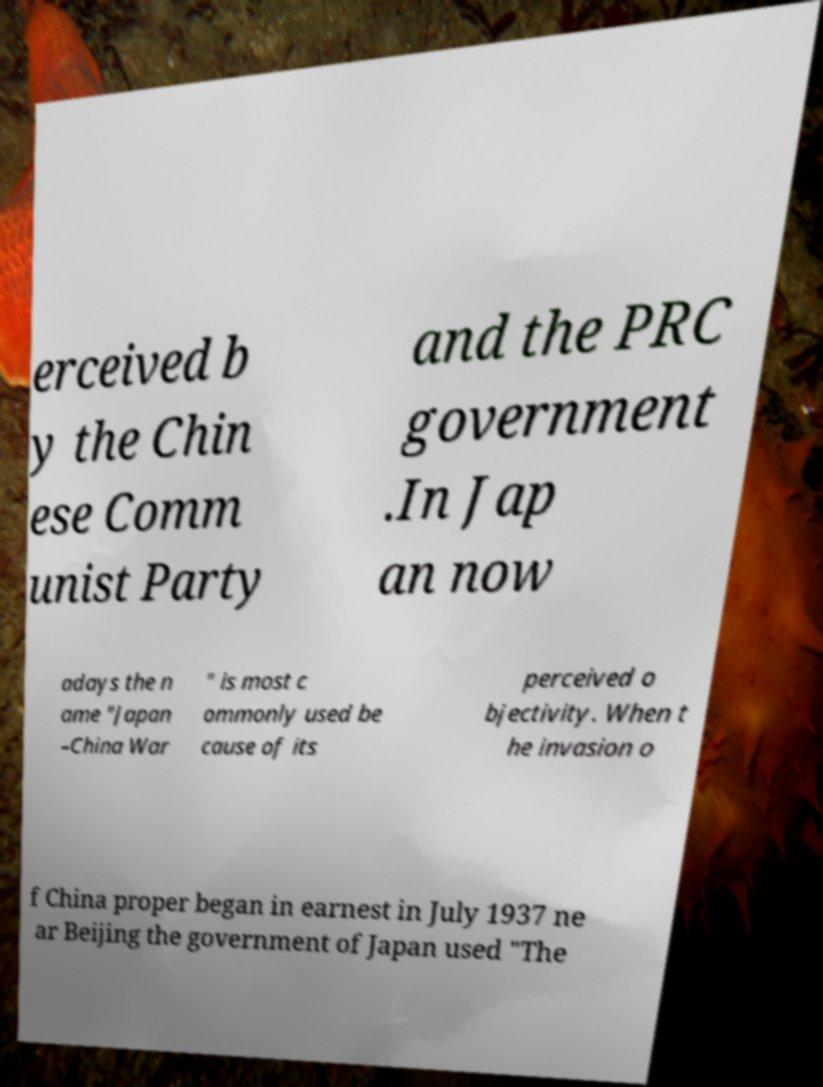Could you extract and type out the text from this image? erceived b y the Chin ese Comm unist Party and the PRC government .In Jap an now adays the n ame "Japan –China War " is most c ommonly used be cause of its perceived o bjectivity. When t he invasion o f China proper began in earnest in July 1937 ne ar Beijing the government of Japan used "The 